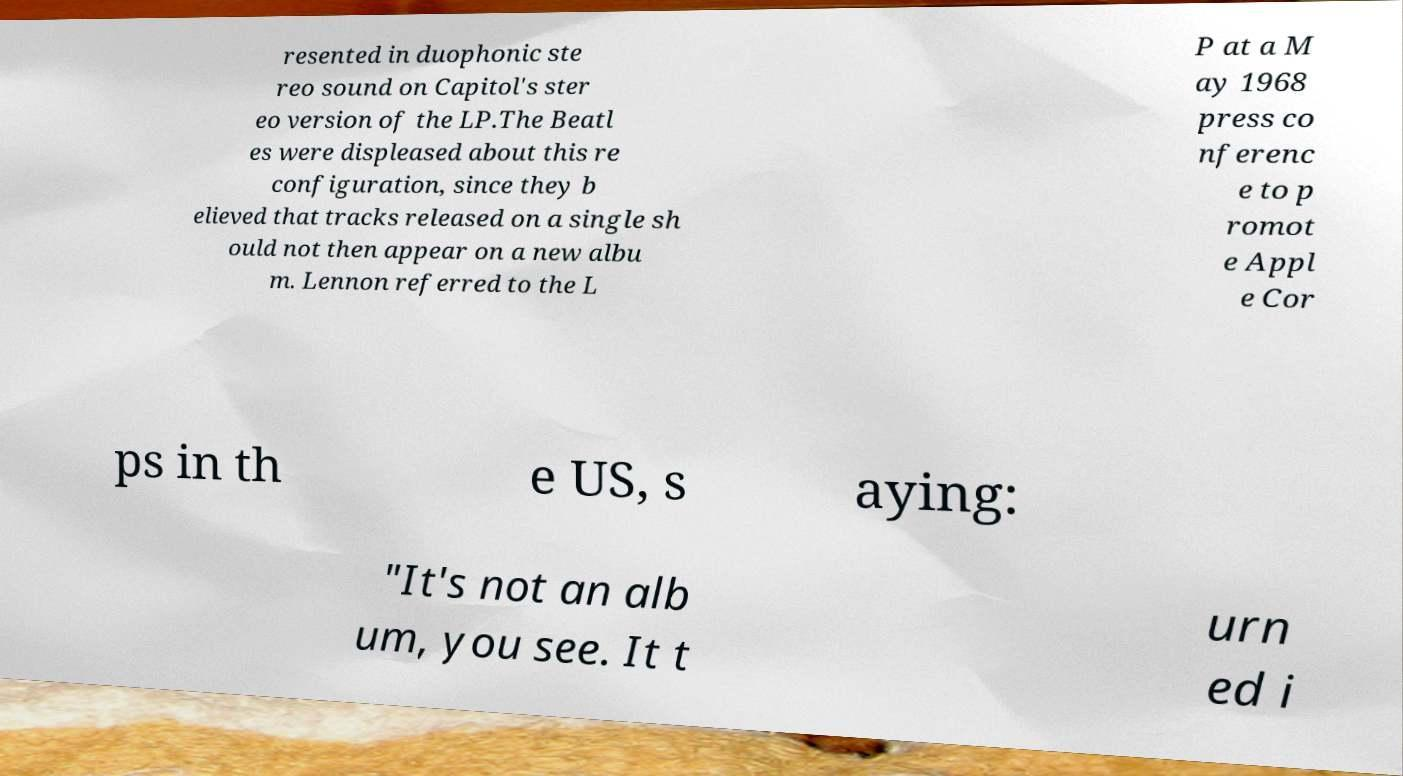Please identify and transcribe the text found in this image. resented in duophonic ste reo sound on Capitol's ster eo version of the LP.The Beatl es were displeased about this re configuration, since they b elieved that tracks released on a single sh ould not then appear on a new albu m. Lennon referred to the L P at a M ay 1968 press co nferenc e to p romot e Appl e Cor ps in th e US, s aying: "It's not an alb um, you see. It t urn ed i 